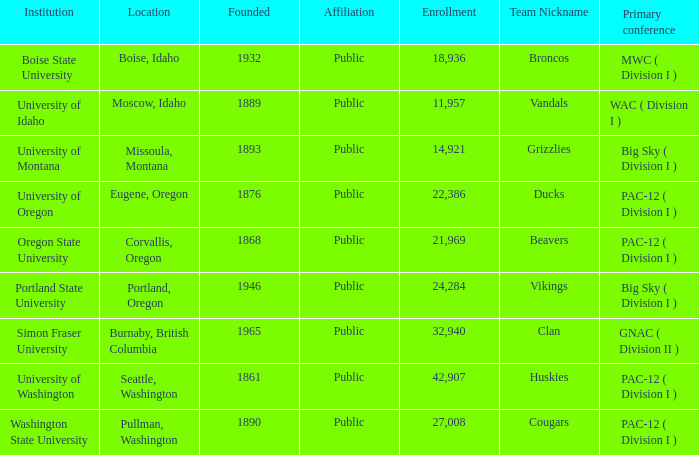Where can the team known as the broncos, established post-1889, be found? Boise, Idaho. 